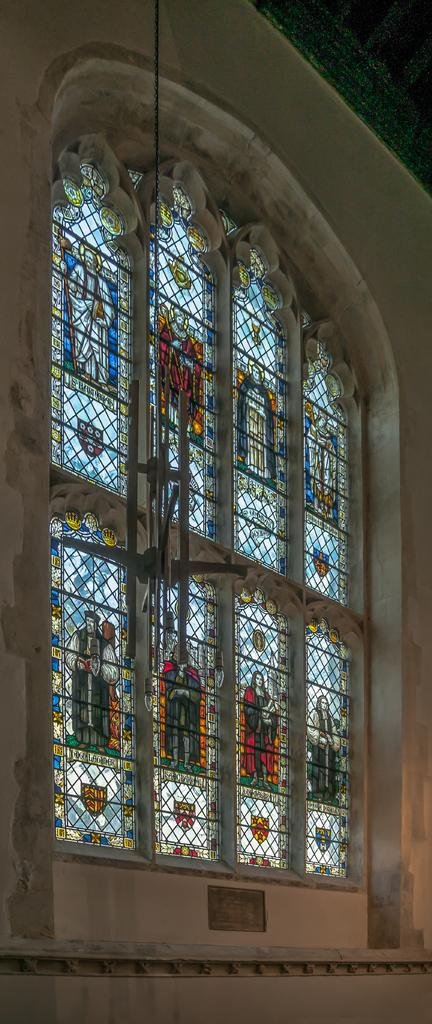What is located in the center of the image? There is a window in the center of the image. What can be seen on the window? There are pictures of some persons on the window. What else is visible in the image besides the window? There is a wall visible in the image. What type of wire is used to hang the salt on the window? There is no wire or salt present in the image; it only features a window with pictures of persons and a wall. 